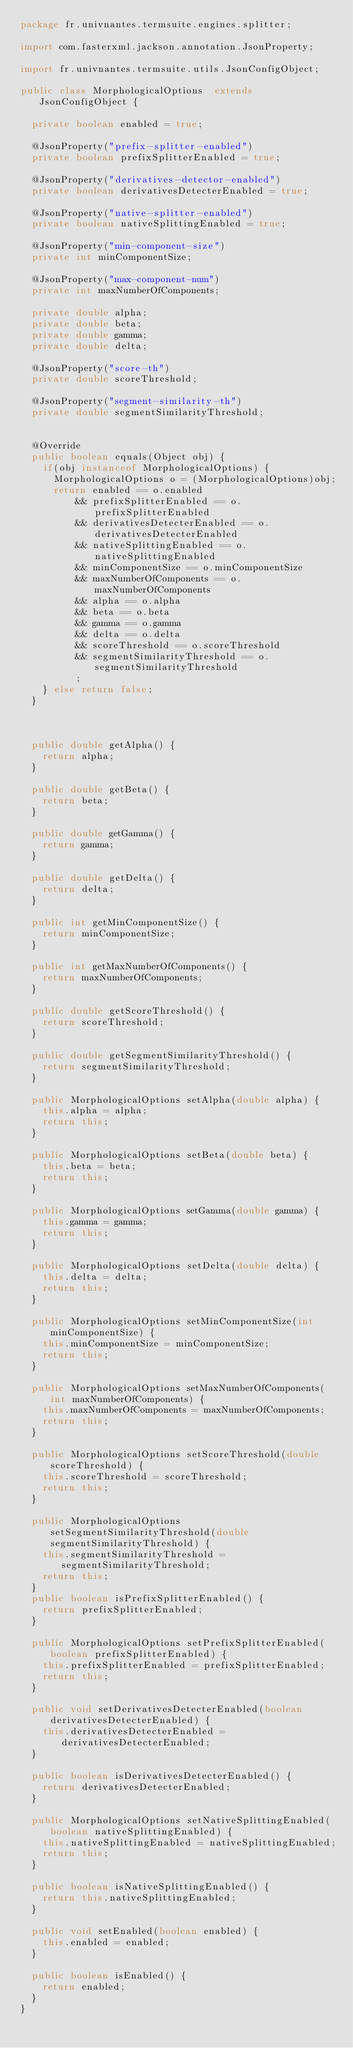Convert code to text. <code><loc_0><loc_0><loc_500><loc_500><_Java_>package fr.univnantes.termsuite.engines.splitter;

import com.fasterxml.jackson.annotation.JsonProperty;

import fr.univnantes.termsuite.utils.JsonConfigObject;

public class MorphologicalOptions  extends JsonConfigObject {

	private boolean enabled = true;
	
	@JsonProperty("prefix-splitter-enabled")
	private boolean prefixSplitterEnabled = true;

	@JsonProperty("derivatives-detector-enabled")
	private boolean derivativesDetecterEnabled = true;
	
	@JsonProperty("native-splitter-enabled")
	private boolean nativeSplittingEnabled = true;

	@JsonProperty("min-component-size")
	private int minComponentSize;

	@JsonProperty("max-component-num")
	private int maxNumberOfComponents;

	private double alpha;
	private double beta;
	private double gamma;
	private double delta;
	
	@JsonProperty("score-th")
	private double scoreThreshold;

	@JsonProperty("segment-similarity-th")
	private double segmentSimilarityThreshold;
	
	
	@Override
	public boolean equals(Object obj) {
		if(obj instanceof MorphologicalOptions) {
			MorphologicalOptions o = (MorphologicalOptions)obj;
			return enabled == o.enabled
					&& prefixSplitterEnabled == o.prefixSplitterEnabled
					&& derivativesDetecterEnabled == o.derivativesDetecterEnabled
					&& nativeSplittingEnabled == o.nativeSplittingEnabled
					&& minComponentSize == o.minComponentSize
					&& maxNumberOfComponents == o.maxNumberOfComponents
					&& alpha == o.alpha
					&& beta == o.beta
					&& gamma == o.gamma
					&& delta == o.delta
					&& scoreThreshold == o.scoreThreshold
					&& segmentSimilarityThreshold == o.segmentSimilarityThreshold
					;
		} else return false;
	}


	
	public double getAlpha() {
		return alpha;
	}
	
	public double getBeta() {
		return beta;
	}
	
	public double getGamma() {
		return gamma;
	}
	
	public double getDelta() {
		return delta;
	}
	
	public int getMinComponentSize() {
		return minComponentSize;
	}
	
	public int getMaxNumberOfComponents() {
		return maxNumberOfComponents;
	}
	
	public double getScoreThreshold() {
		return scoreThreshold;
	}
	
	public double getSegmentSimilarityThreshold() {
		return segmentSimilarityThreshold;
	}

	public MorphologicalOptions setAlpha(double alpha) {
		this.alpha = alpha;
		return this;
	}

	public MorphologicalOptions setBeta(double beta) {
		this.beta = beta;
		return this;
	}

	public MorphologicalOptions setGamma(double gamma) {
		this.gamma = gamma;
		return this;
	}

	public MorphologicalOptions setDelta(double delta) {
		this.delta = delta;
		return this;
	}

	public MorphologicalOptions setMinComponentSize(int minComponentSize) {
		this.minComponentSize = minComponentSize;
		return this;
	}

	public MorphologicalOptions setMaxNumberOfComponents(int maxNumberOfComponents) {
		this.maxNumberOfComponents = maxNumberOfComponents;
		return this;
	}

	public MorphologicalOptions setScoreThreshold(double scoreThreshold) {
		this.scoreThreshold = scoreThreshold;
		return this;
	}
	
	public MorphologicalOptions setSegmentSimilarityThreshold(double segmentSimilarityThreshold) {
		this.segmentSimilarityThreshold = segmentSimilarityThreshold;
		return this;
	}
	public boolean isPrefixSplitterEnabled() {
		return prefixSplitterEnabled;
	}
	
	public MorphologicalOptions setPrefixSplitterEnabled(boolean prefixSplitterEnabled) {
		this.prefixSplitterEnabled = prefixSplitterEnabled;
		return this;
	}
	
	public void setDerivativesDetecterEnabled(boolean derivativesDetecterEnabled) {
		this.derivativesDetecterEnabled = derivativesDetecterEnabled;
	}
	
	public boolean isDerivativesDetecterEnabled() {
		return derivativesDetecterEnabled;
	}
	
	public MorphologicalOptions setNativeSplittingEnabled(boolean nativeSplittingEnabled) {
		this.nativeSplittingEnabled = nativeSplittingEnabled;
		return this;
	}
	
	public boolean isNativeSplittingEnabled() {
		return this.nativeSplittingEnabled;
	}
	
	public void setEnabled(boolean enabled) {
		this.enabled = enabled;
	}
	
	public boolean isEnabled() {
		return enabled;
	}
}
</code> 